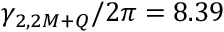<formula> <loc_0><loc_0><loc_500><loc_500>\gamma _ { 2 , 2 M + Q } / 2 \pi = 8 . 3 9</formula> 